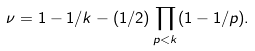<formula> <loc_0><loc_0><loc_500><loc_500>\nu = 1 - 1 / k - ( 1 / 2 ) \prod _ { p < k } ( 1 - 1 / p ) .</formula> 